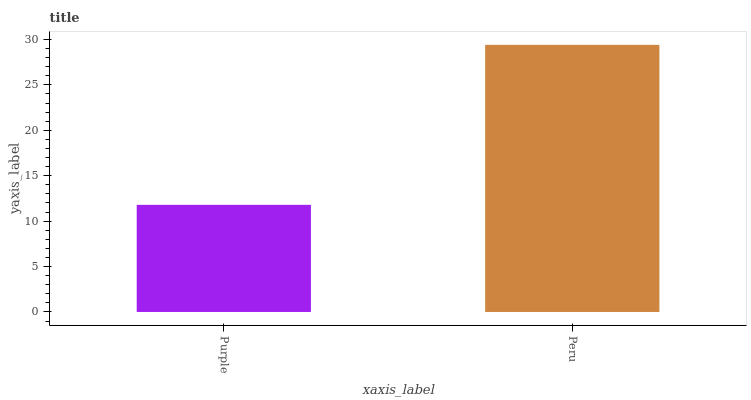Is Purple the minimum?
Answer yes or no. Yes. Is Peru the maximum?
Answer yes or no. Yes. Is Peru the minimum?
Answer yes or no. No. Is Peru greater than Purple?
Answer yes or no. Yes. Is Purple less than Peru?
Answer yes or no. Yes. Is Purple greater than Peru?
Answer yes or no. No. Is Peru less than Purple?
Answer yes or no. No. Is Peru the high median?
Answer yes or no. Yes. Is Purple the low median?
Answer yes or no. Yes. Is Purple the high median?
Answer yes or no. No. Is Peru the low median?
Answer yes or no. No. 